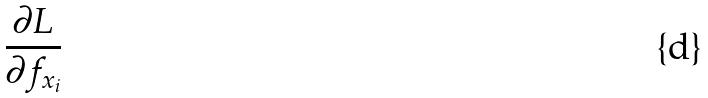Convert formula to latex. <formula><loc_0><loc_0><loc_500><loc_500>\frac { \partial L } { \partial f _ { x _ { i } } }</formula> 